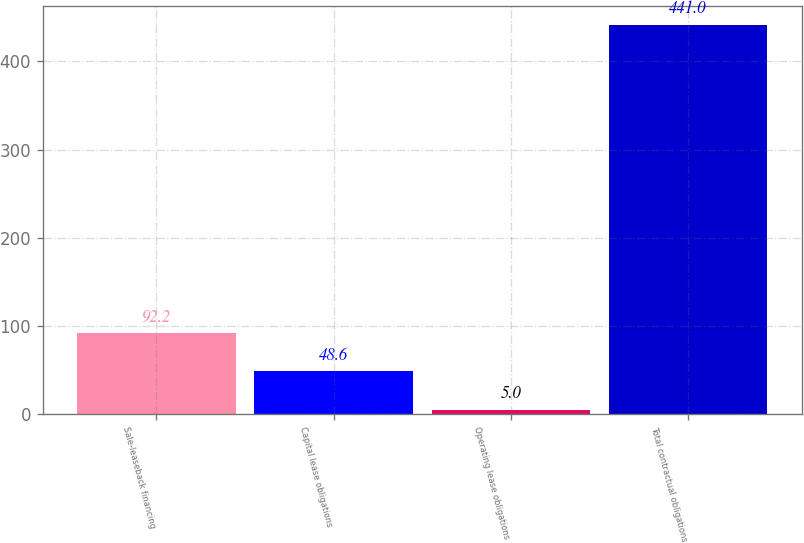Convert chart. <chart><loc_0><loc_0><loc_500><loc_500><bar_chart><fcel>Sale-leaseback financing<fcel>Capital lease obligations<fcel>Operating lease obligations<fcel>Total contractual obligations<nl><fcel>92.2<fcel>48.6<fcel>5<fcel>441<nl></chart> 